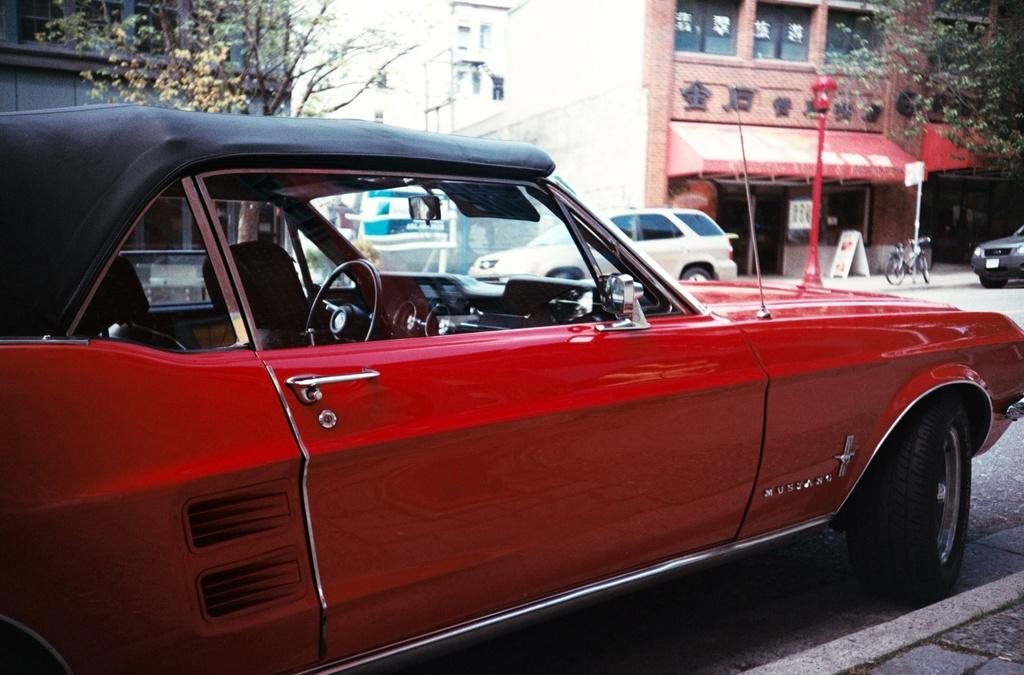What can be seen parked on the road in the image? There is a group of vehicles parked on the road in the image. What is visible in the background of the image? There are trees, buildings, and a pole in the background of the image. How many oranges are hanging from the trees in the image? There are no oranges visible in the image; only trees, buildings, and a pole can be seen in the background. Where are the rabbits located in the image? There are no rabbits present in the image. 